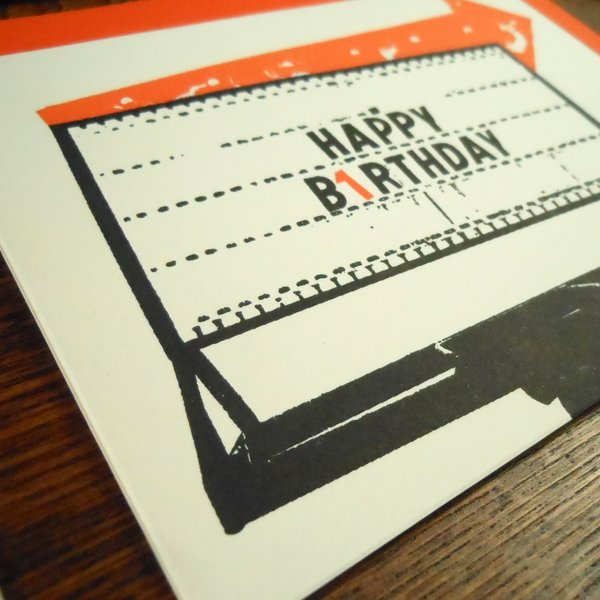What is the significance of the smudge effect on the "HAPPY BIRTHDAY" text? The smudge effect on the "HAPPY BIRTHDAY" text adds a sense of authenticity and charm to the card's vintage design. This design choice emulates the imperfections commonly found in text produced by old typewriters, where ink could smudge or letters might not align perfectly due to uneven key presses or over-inked ribbons. It appeals to nostalgia, invoking the tactile and visual qualities associated with typewriters, and creates a connection to a bygone era when these mechanical devices were prominent. Such design details not only enhance the aesthetic appeal of the card but also evoke sentimental feelings, making the birthday greeting more memorable and personal. 